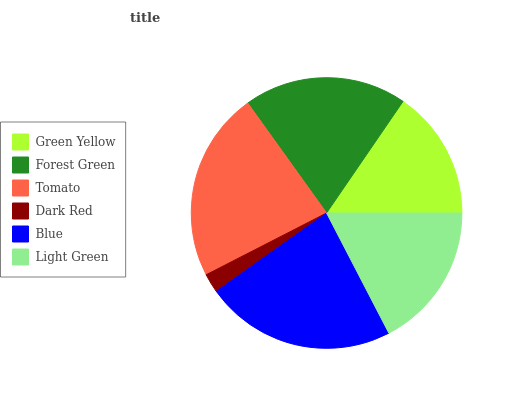Is Dark Red the minimum?
Answer yes or no. Yes. Is Blue the maximum?
Answer yes or no. Yes. Is Forest Green the minimum?
Answer yes or no. No. Is Forest Green the maximum?
Answer yes or no. No. Is Forest Green greater than Green Yellow?
Answer yes or no. Yes. Is Green Yellow less than Forest Green?
Answer yes or no. Yes. Is Green Yellow greater than Forest Green?
Answer yes or no. No. Is Forest Green less than Green Yellow?
Answer yes or no. No. Is Forest Green the high median?
Answer yes or no. Yes. Is Light Green the low median?
Answer yes or no. Yes. Is Blue the high median?
Answer yes or no. No. Is Tomato the low median?
Answer yes or no. No. 